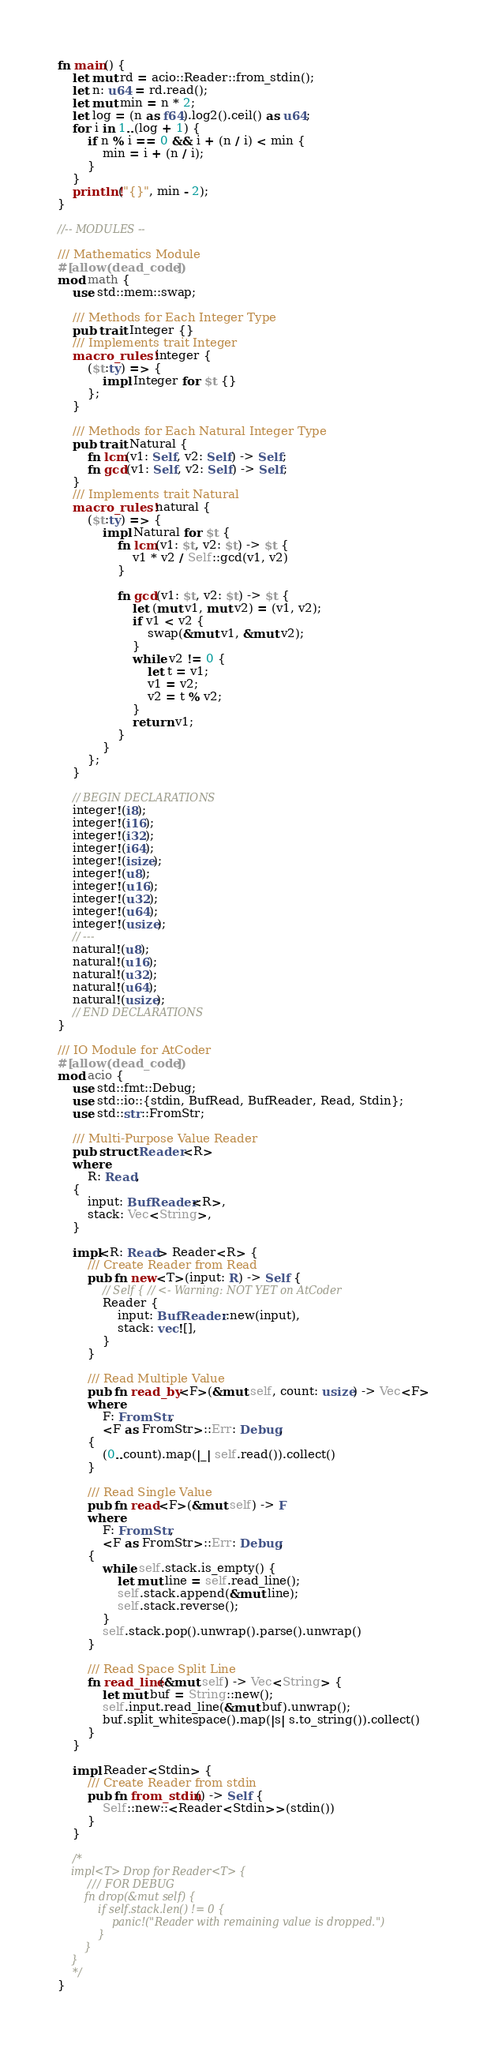Convert code to text. <code><loc_0><loc_0><loc_500><loc_500><_Rust_>fn main() {
    let mut rd = acio::Reader::from_stdin();
    let n: u64 = rd.read();
    let mut min = n * 2;
    let log = (n as f64).log2().ceil() as u64;
    for i in 1..(log + 1) {
        if n % i == 0 && i + (n / i) < min {
            min = i + (n / i);
        }
    }
    println!("{}", min - 2);
}

//-- MODULES --

/// Mathematics Module
#[allow(dead_code)]
mod math {
    use std::mem::swap;

    /// Methods for Each Integer Type
    pub trait Integer {}
    /// Implements trait Integer
    macro_rules! integer {
        ($t:ty) => {
            impl Integer for $t {}
        };
    }

    /// Methods for Each Natural Integer Type
    pub trait Natural {
        fn lcm(v1: Self, v2: Self) -> Self;
        fn gcd(v1: Self, v2: Self) -> Self;
    }
    /// Implements trait Natural
    macro_rules! natural {
        ($t:ty) => {
            impl Natural for $t {
                fn lcm(v1: $t, v2: $t) -> $t {
                    v1 * v2 / Self::gcd(v1, v2)
                }

                fn gcd(v1: $t, v2: $t) -> $t {
                    let (mut v1, mut v2) = (v1, v2);
                    if v1 < v2 {
                        swap(&mut v1, &mut v2);
                    }
                    while v2 != 0 {
                        let t = v1;
                        v1 = v2;
                        v2 = t % v2;
                    }
                    return v1;
                }
            }
        };
    }

    // BEGIN DECLARATIONS
    integer!(i8);
    integer!(i16);
    integer!(i32);
    integer!(i64);
    integer!(isize);
    integer!(u8);
    integer!(u16);
    integer!(u32);
    integer!(u64);
    integer!(usize);
    // ---
    natural!(u8);
    natural!(u16);
    natural!(u32);
    natural!(u64);
    natural!(usize);
    // END DECLARATIONS
}

/// IO Module for AtCoder
#[allow(dead_code)]
mod acio {
    use std::fmt::Debug;
    use std::io::{stdin, BufRead, BufReader, Read, Stdin};
    use std::str::FromStr;

    /// Multi-Purpose Value Reader
    pub struct Reader<R>
    where
        R: Read,
    {
        input: BufReader<R>,
        stack: Vec<String>,
    }

    impl<R: Read> Reader<R> {
        /// Create Reader from Read
        pub fn new<T>(input: R) -> Self {
            // Self { // <- Warning: NOT YET on AtCoder
            Reader {
                input: BufReader::new(input),
                stack: vec![],
            }
        }

        /// Read Multiple Value
        pub fn read_by<F>(&mut self, count: usize) -> Vec<F>
        where
            F: FromStr,
            <F as FromStr>::Err: Debug,
        {
            (0..count).map(|_| self.read()).collect()
        }

        /// Read Single Value
        pub fn read<F>(&mut self) -> F
        where
            F: FromStr,
            <F as FromStr>::Err: Debug,
        {
            while self.stack.is_empty() {
                let mut line = self.read_line();
                self.stack.append(&mut line);
                self.stack.reverse();
            }
            self.stack.pop().unwrap().parse().unwrap()
        }

        /// Read Space Split Line
        fn read_line(&mut self) -> Vec<String> {
            let mut buf = String::new();
            self.input.read_line(&mut buf).unwrap();
            buf.split_whitespace().map(|s| s.to_string()).collect()
        }
    }

    impl Reader<Stdin> {
        /// Create Reader from stdin
        pub fn from_stdin() -> Self {
            Self::new::<Reader<Stdin>>(stdin())
        }
    }

    /*
    impl<T> Drop for Reader<T> {
        /// FOR DEBUG
        fn drop(&mut self) {
            if self.stack.len() != 0 {
                panic!("Reader with remaining value is dropped.")
            }
        }
    }
    */
}
</code> 